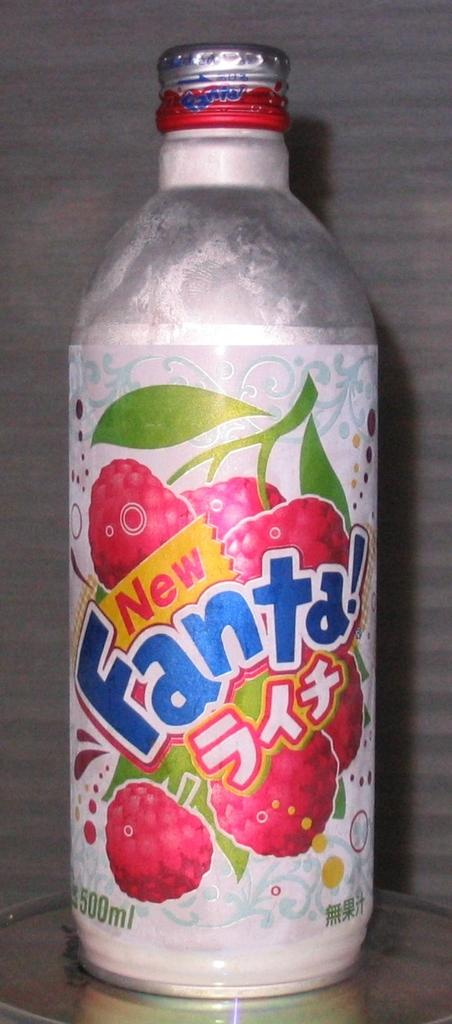What can be seen in the image? There is a bottle in the image. Can you describe the bottle in more detail? Yes, there is a label on the bottle. What type of gate is present in the image? There is no gate present in the image; it only features a bottle with a label. 